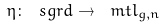Convert formula to latex. <formula><loc_0><loc_0><loc_500><loc_500>\eta \colon \ s g r d \to \ m t l _ { g , n }</formula> 